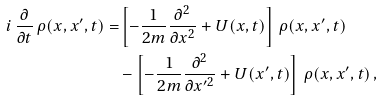Convert formula to latex. <formula><loc_0><loc_0><loc_500><loc_500>i \, \frac { \partial } { \partial t } \, \rho ( x , x ^ { \prime } , t ) = & \left [ - \frac { 1 } { 2 m } \frac { \partial ^ { 2 } } { \partial x ^ { 2 } } + U ( x , t ) \right ] \, \rho ( x , x ^ { \prime } , t ) \\ & - \left [ - \frac { 1 } { 2 m } \frac { \partial ^ { 2 } } { \partial x ^ { \prime 2 } } + U ( x ^ { \prime } , t ) \right ] \, \rho ( x , x ^ { \prime } , t ) \, ,</formula> 